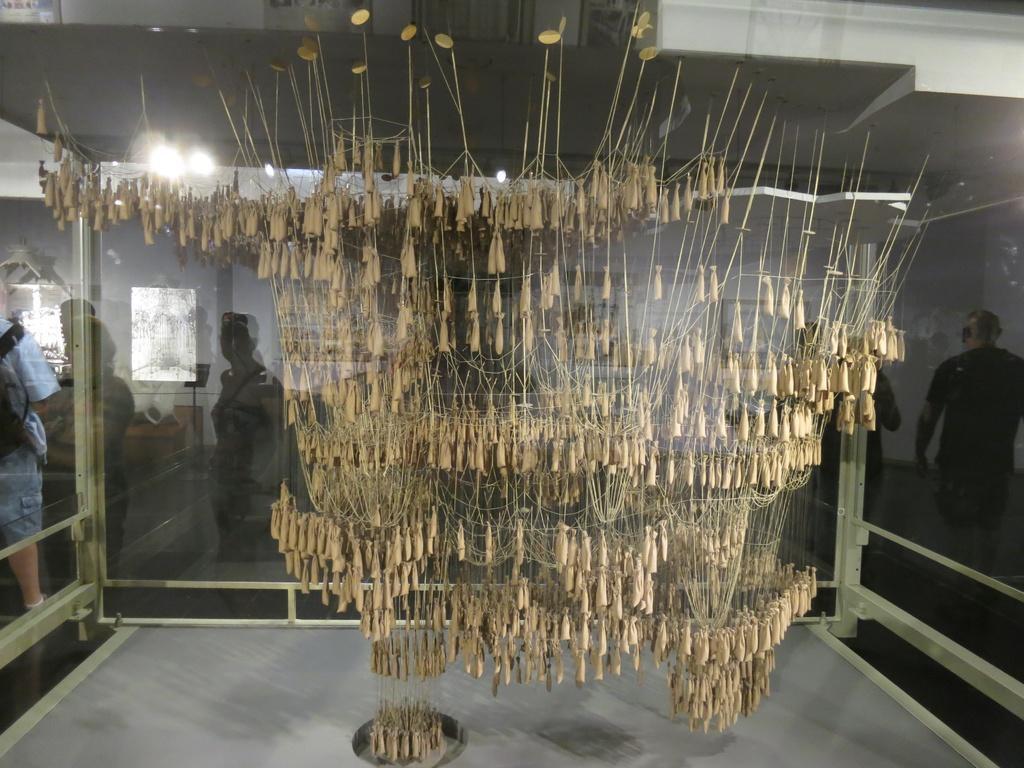Describe this image in one or two sentences. This picture is clicked inside. In the center we can see there are some objects which seems to be a chandelier hanging on the roof and we can see the lights and group of persons in the background. 